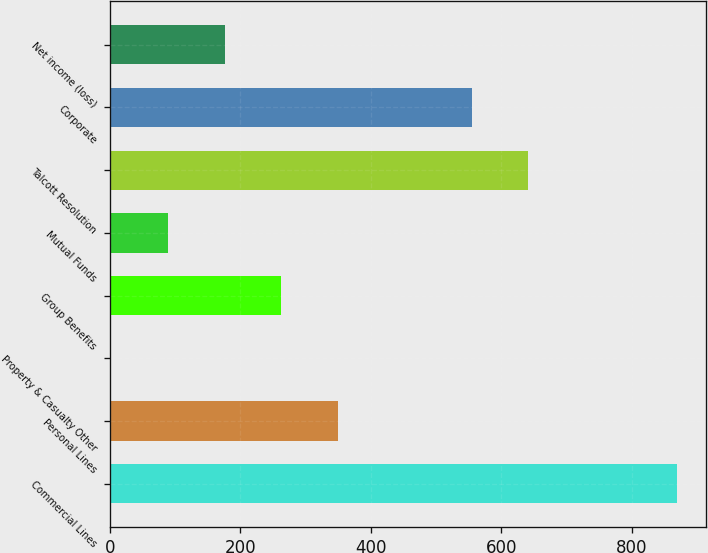<chart> <loc_0><loc_0><loc_500><loc_500><bar_chart><fcel>Commercial Lines<fcel>Personal Lines<fcel>Property & Casualty Other<fcel>Group Benefits<fcel>Mutual Funds<fcel>Talcott Resolution<fcel>Corporate<fcel>Net income (loss)<nl><fcel>870<fcel>349.6<fcel>2<fcel>262.8<fcel>88.8<fcel>641.8<fcel>555<fcel>176<nl></chart> 